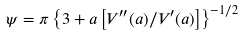Convert formula to latex. <formula><loc_0><loc_0><loc_500><loc_500>\psi = \pi \left \{ 3 + a \left [ V ^ { \prime \prime } ( a ) / V ^ { \prime } ( a ) \right ] \right \} ^ { - 1 / 2 }</formula> 